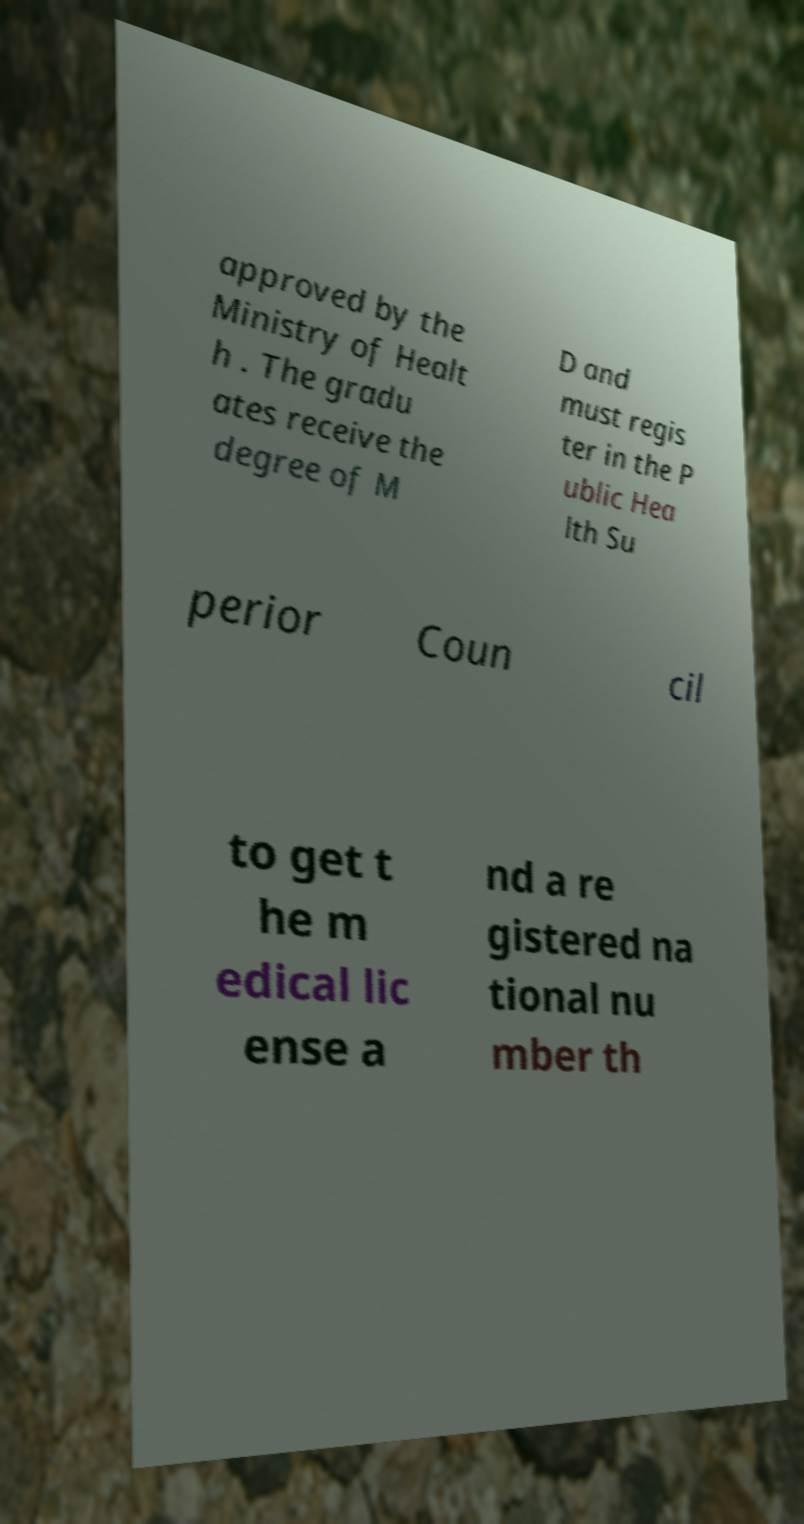For documentation purposes, I need the text within this image transcribed. Could you provide that? approved by the Ministry of Healt h . The gradu ates receive the degree of M D and must regis ter in the P ublic Hea lth Su perior Coun cil to get t he m edical lic ense a nd a re gistered na tional nu mber th 